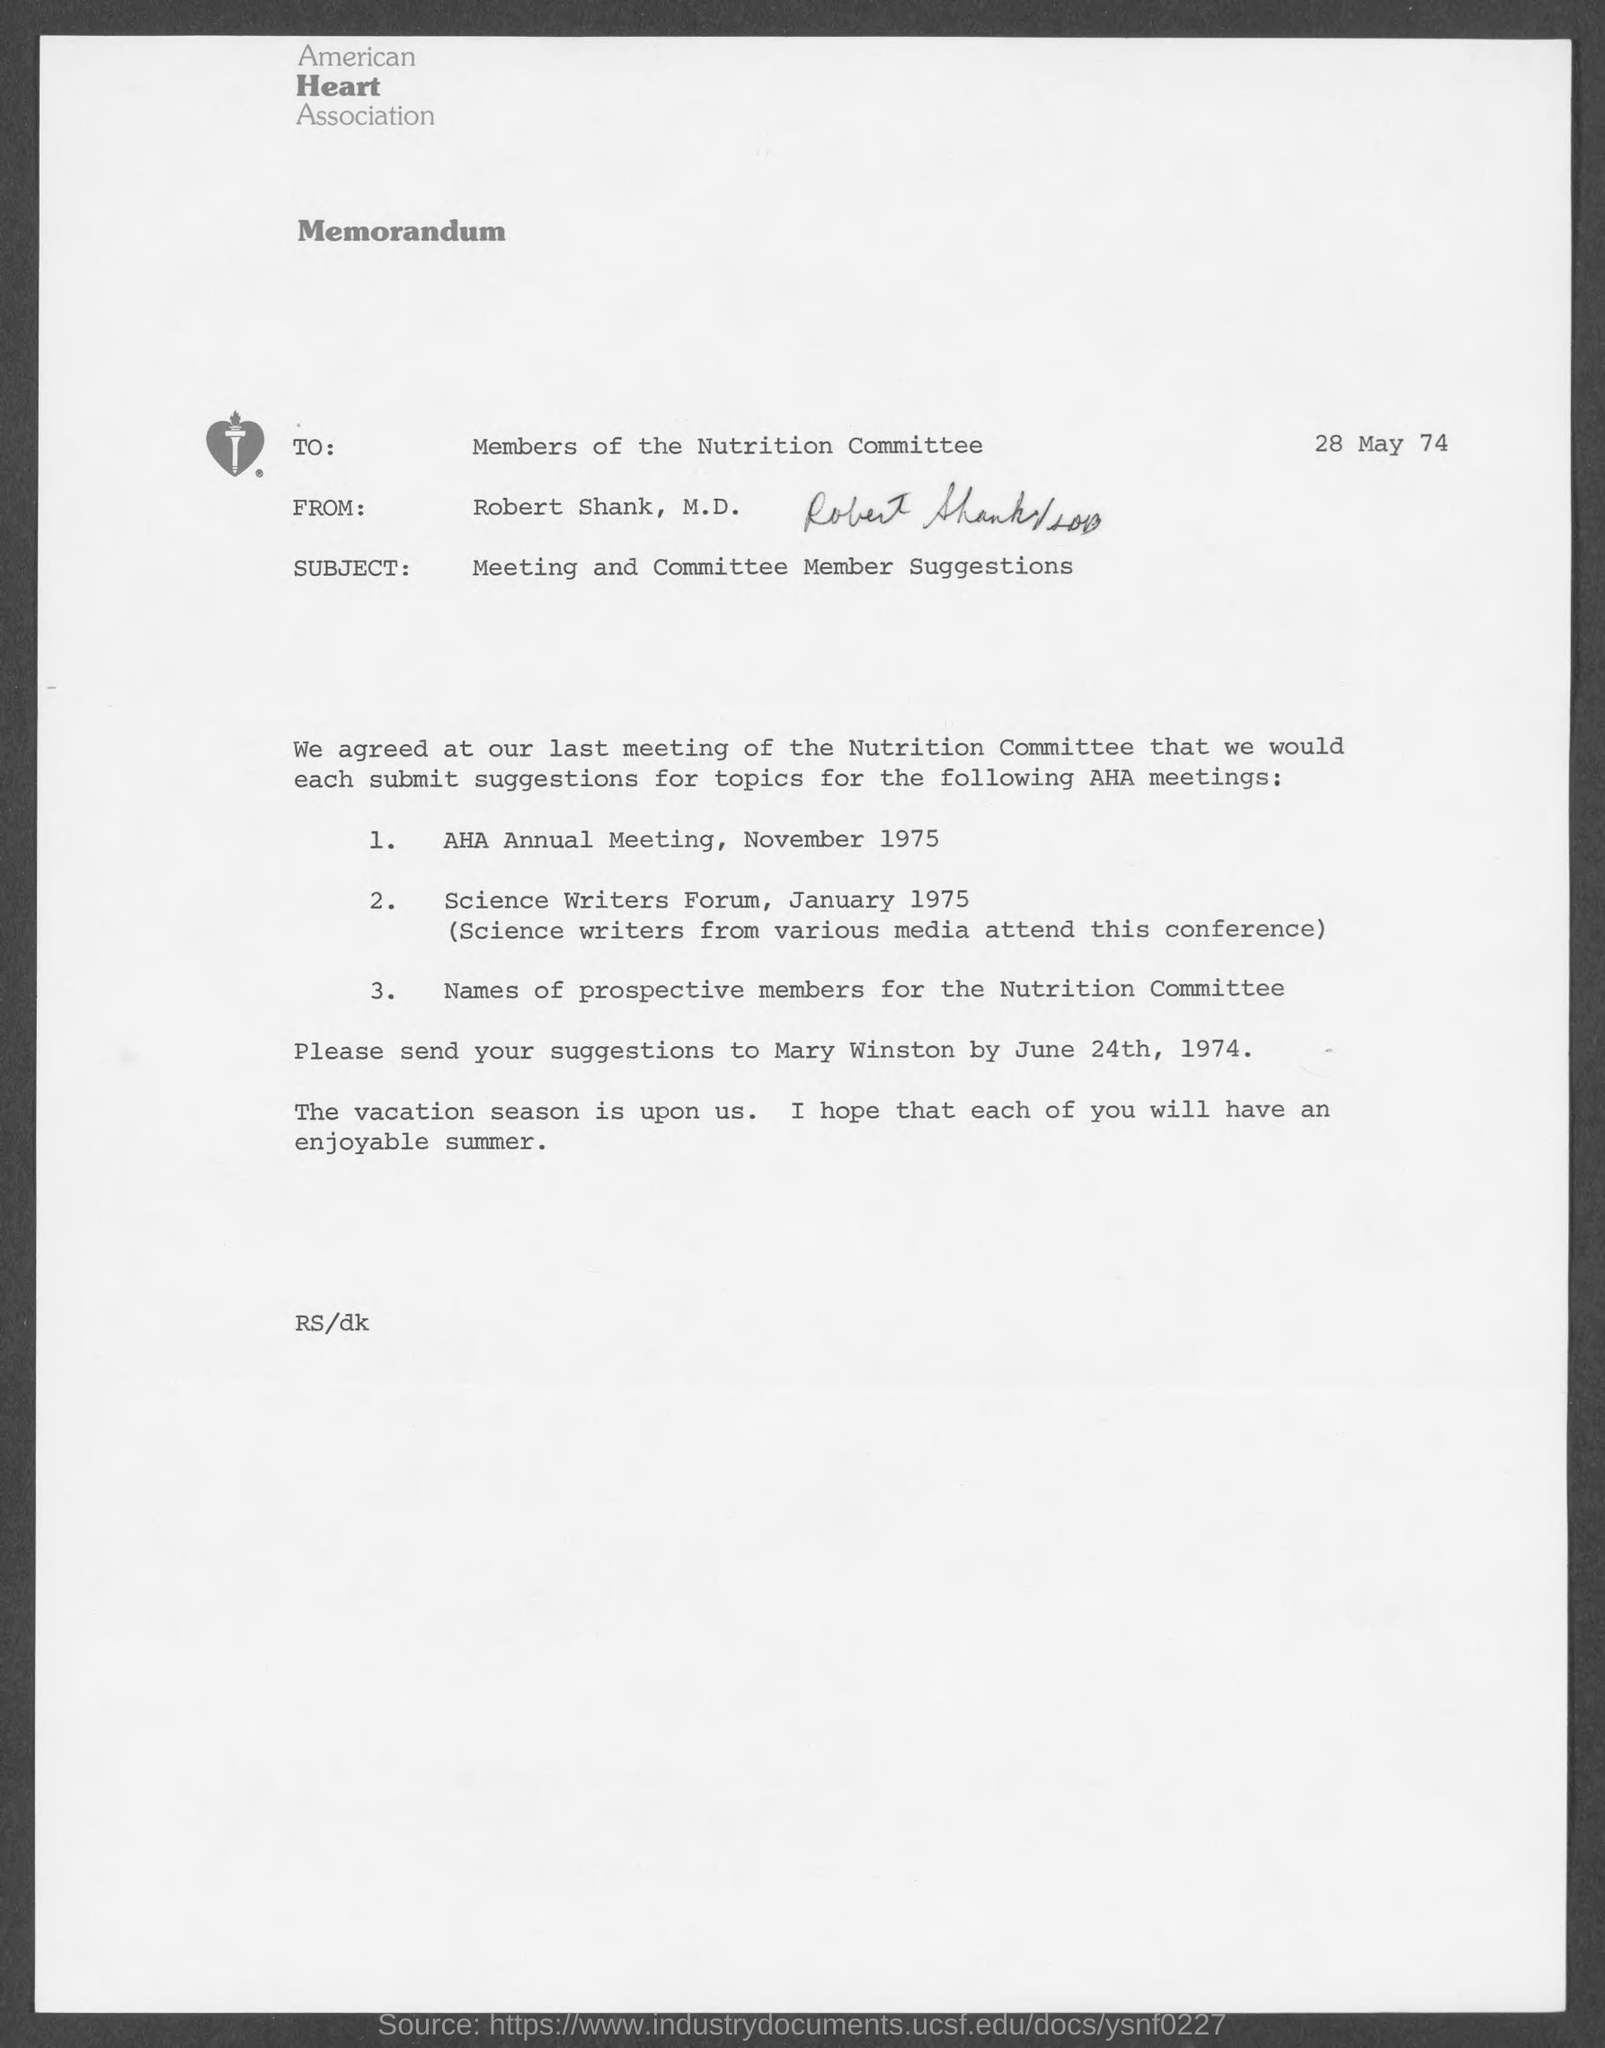Specify some key components in this picture. The AHA Annual Meeting was scheduled for November 1975. The subject of the memorandum is the discussion of Meeting and Committee Member Suggestions. The from address in a memorandum is 'Robert Shank, M.D.'," as stated. The Science Writers Forum was held on January 1975. The American Heart Association is the name of the heart association that is located at the top of the page. 